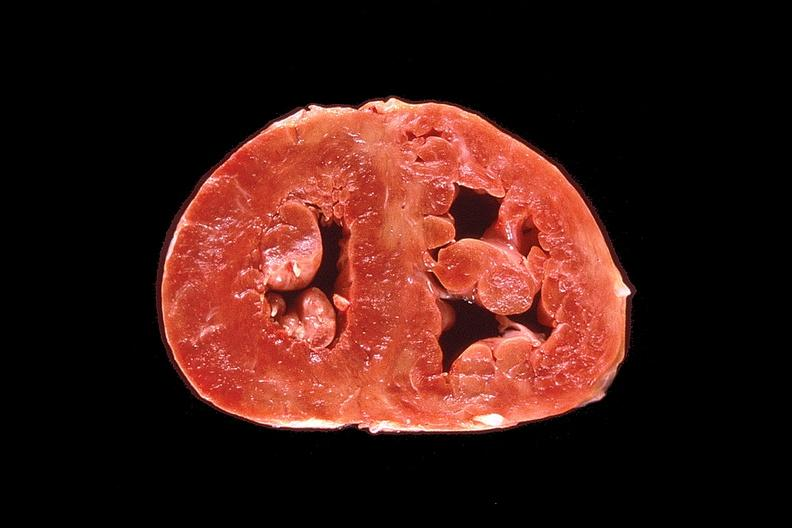s cachexia present?
Answer the question using a single word or phrase. No 